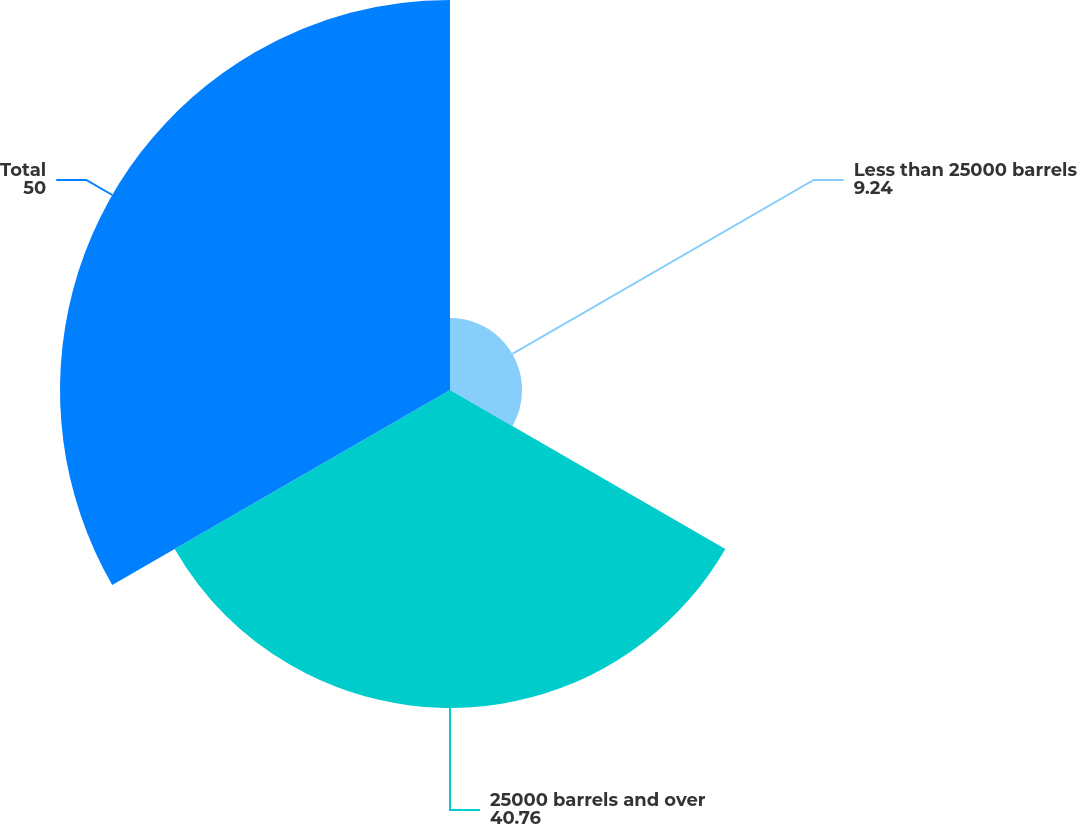Convert chart to OTSL. <chart><loc_0><loc_0><loc_500><loc_500><pie_chart><fcel>Less than 25000 barrels<fcel>25000 barrels and over<fcel>Total<nl><fcel>9.24%<fcel>40.76%<fcel>50.0%<nl></chart> 